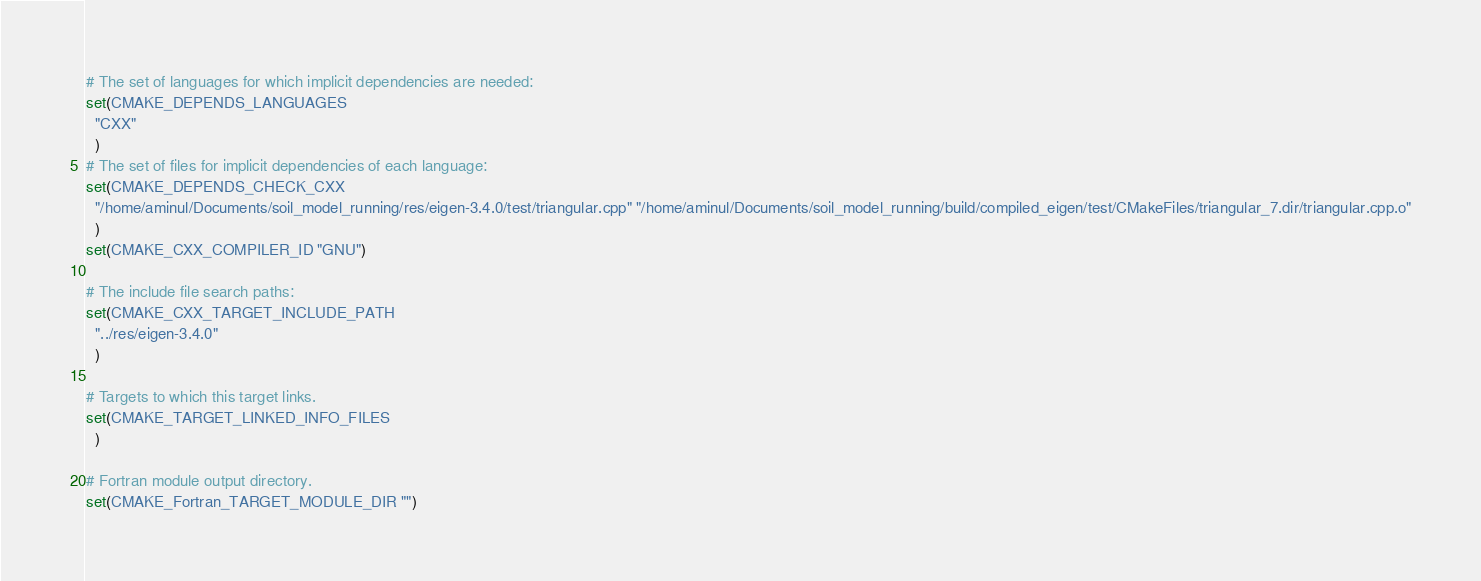Convert code to text. <code><loc_0><loc_0><loc_500><loc_500><_CMake_># The set of languages for which implicit dependencies are needed:
set(CMAKE_DEPENDS_LANGUAGES
  "CXX"
  )
# The set of files for implicit dependencies of each language:
set(CMAKE_DEPENDS_CHECK_CXX
  "/home/aminul/Documents/soil_model_running/res/eigen-3.4.0/test/triangular.cpp" "/home/aminul/Documents/soil_model_running/build/compiled_eigen/test/CMakeFiles/triangular_7.dir/triangular.cpp.o"
  )
set(CMAKE_CXX_COMPILER_ID "GNU")

# The include file search paths:
set(CMAKE_CXX_TARGET_INCLUDE_PATH
  "../res/eigen-3.4.0"
  )

# Targets to which this target links.
set(CMAKE_TARGET_LINKED_INFO_FILES
  )

# Fortran module output directory.
set(CMAKE_Fortran_TARGET_MODULE_DIR "")
</code> 